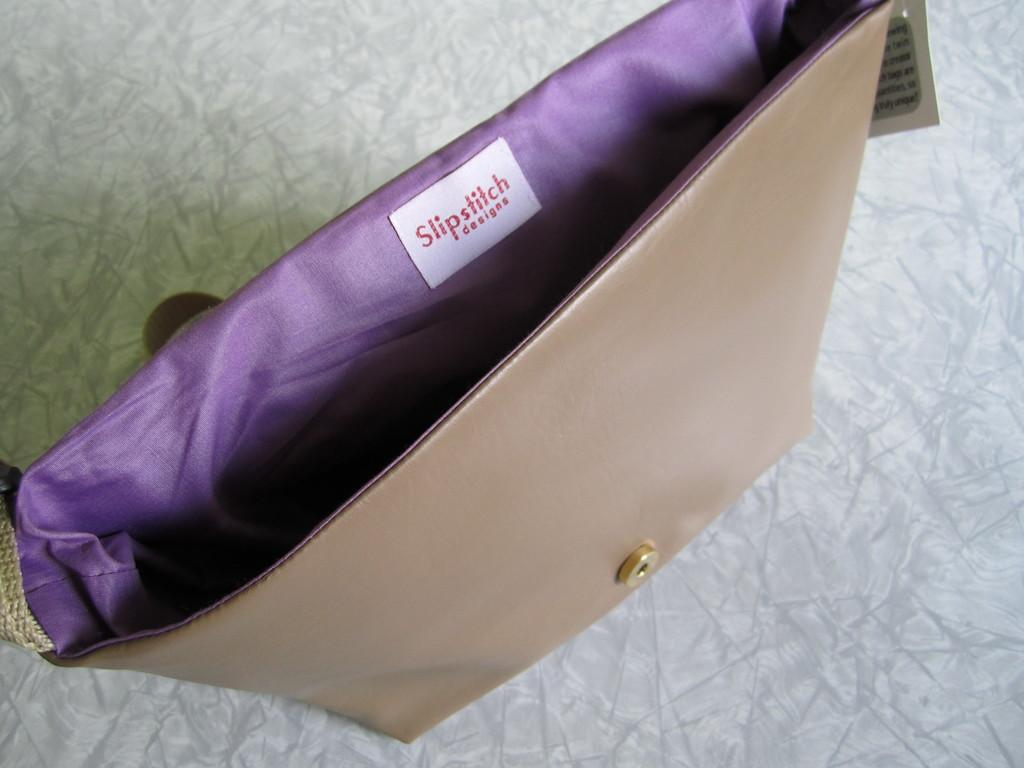What object can be seen in the image? There is a bag in the image. Can you describe the appearance of the bag? The bag is cream white and blue in color. What type of jelly can be seen in the wilderness in the image? There is no jelly or wilderness present in the image; it only features a bag. 